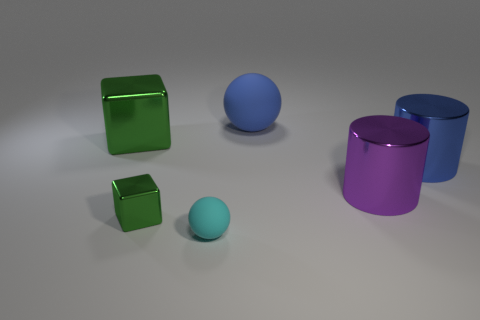There is a shiny cube on the left side of the small shiny cube; does it have the same size as the object in front of the tiny metallic block?
Offer a terse response. No. The object that is on the right side of the purple thing that is right of the small ball is what color?
Keep it short and to the point. Blue. There is a block that is the same size as the cyan rubber ball; what is its material?
Offer a terse response. Metal. What number of metallic objects are either tiny cylinders or green blocks?
Ensure brevity in your answer.  2. The shiny object that is both left of the purple thing and behind the tiny metal thing is what color?
Offer a very short reply. Green. There is a tiny green cube; how many green things are left of it?
Keep it short and to the point. 1. What is the large purple object made of?
Offer a very short reply. Metal. What color is the matte object that is to the left of the matte object behind the block that is on the right side of the big green thing?
Provide a short and direct response. Cyan. What number of yellow cubes have the same size as the blue cylinder?
Provide a succinct answer. 0. There is a block that is behind the tiny green object; what is its color?
Make the answer very short. Green. 